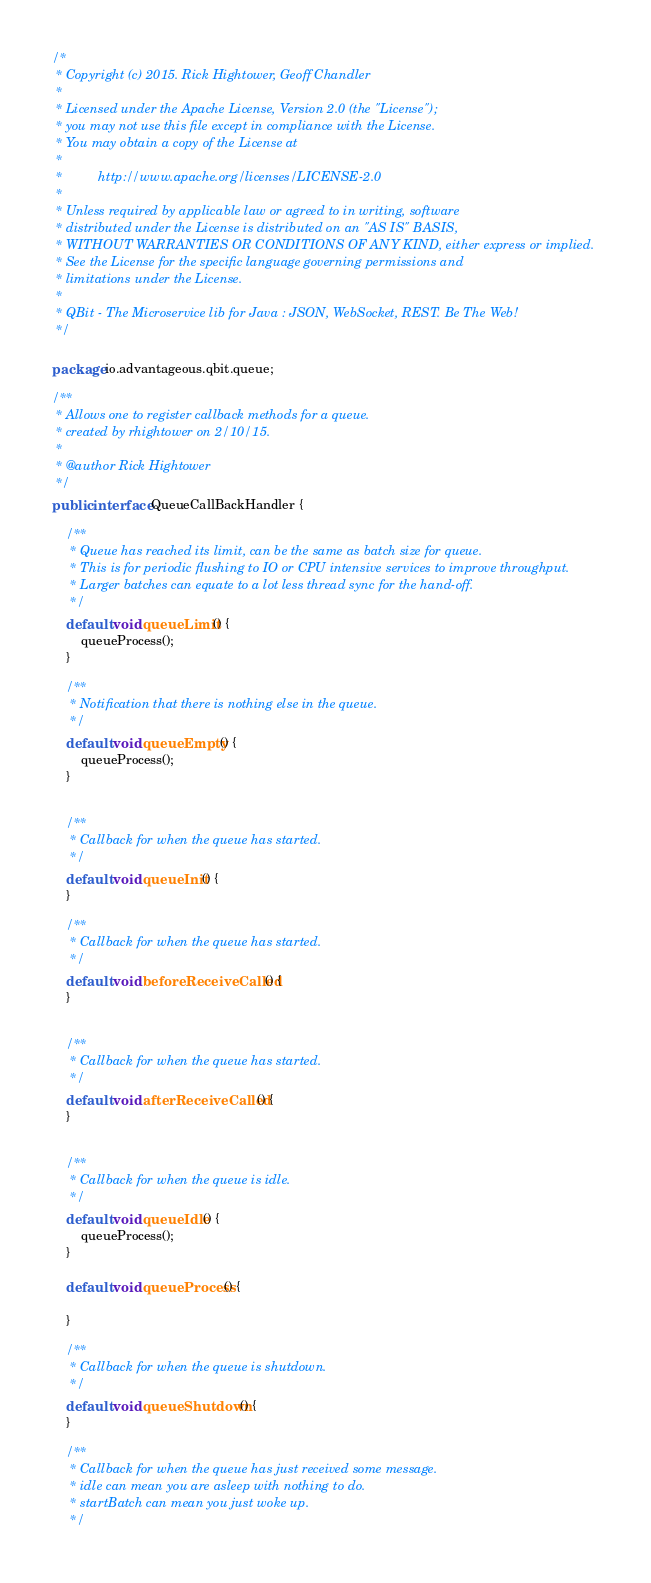Convert code to text. <code><loc_0><loc_0><loc_500><loc_500><_Java_>/*
 * Copyright (c) 2015. Rick Hightower, Geoff Chandler
 *
 * Licensed under the Apache License, Version 2.0 (the "License");
 * you may not use this file except in compliance with the License.
 * You may obtain a copy of the License at
 *
 *  		http://www.apache.org/licenses/LICENSE-2.0
 *
 * Unless required by applicable law or agreed to in writing, software
 * distributed under the License is distributed on an "AS IS" BASIS,
 * WITHOUT WARRANTIES OR CONDITIONS OF ANY KIND, either express or implied.
 * See the License for the specific language governing permissions and
 * limitations under the License.
 *
 * QBit - The Microservice lib for Java : JSON, WebSocket, REST. Be The Web!
 */

package io.advantageous.qbit.queue;

/**
 * Allows one to register callback methods for a queue.
 * created by rhightower on 2/10/15.
 *
 * @author Rick Hightower
 */
public interface QueueCallBackHandler {

    /**
     * Queue has reached its limit, can be the same as batch size for queue.
     * This is for periodic flushing to IO or CPU intensive services to improve throughput.
     * Larger batches can equate to a lot less thread sync for the hand-off.
     */
    default void queueLimit() {
        queueProcess();
    }

    /**
     * Notification that there is nothing else in the queue.
     */
    default void queueEmpty() {
        queueProcess();
    }


    /**
     * Callback for when the queue has started.
     */
    default void queueInit() {
    }

    /**
     * Callback for when the queue has started.
     */
    default void beforeReceiveCalled() {
    }


    /**
     * Callback for when the queue has started.
     */
    default void afterReceiveCalled() {
    }


    /**
     * Callback for when the queue is idle.
     */
    default void queueIdle() {
        queueProcess();
    }

    default void queueProcess() {

    }

    /**
     * Callback for when the queue is shutdown.
     */
    default void queueShutdown() {
    }

    /**
     * Callback for when the queue has just received some message.
     * idle can mean you are asleep with nothing to do.
     * startBatch can mean you just woke up.
     */</code> 